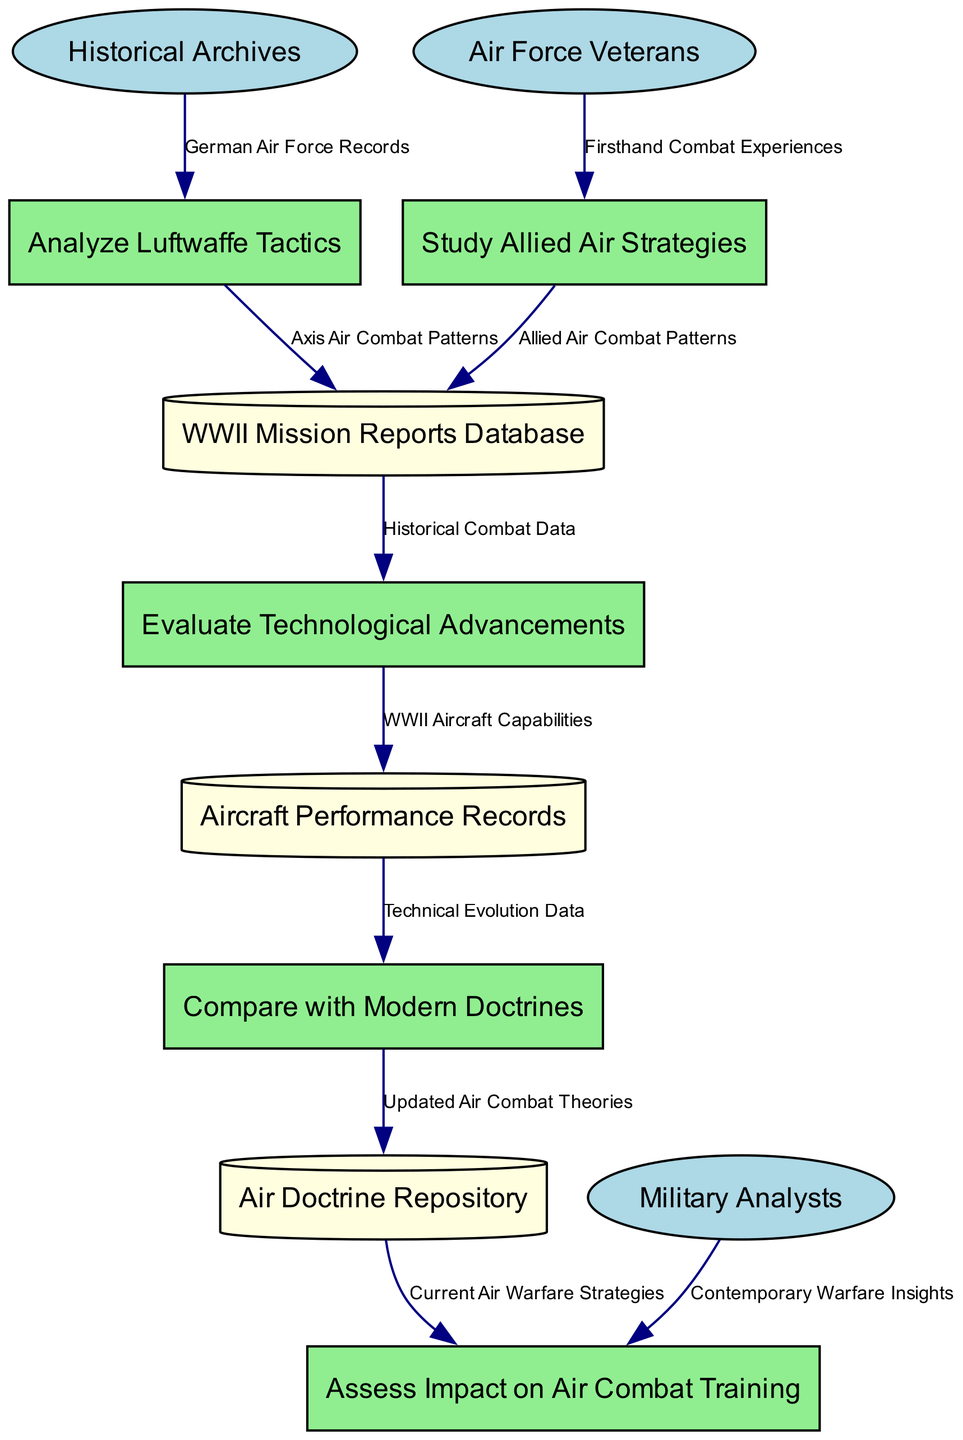What are the external entities involved in the analysis? The diagram lists three external entities: Historical Archives, Air Force Veterans, and Military Analysts. These entities provide data related to the WWII aerial combat analysis.
Answer: Historical Archives, Air Force Veterans, Military Analysts How many processes are present in the diagram? There are five processes in the diagram that relate to the analysis of aerial combat tactics. They include Analyze Luftwaffe Tactics, Study Allied Air Strategies, Evaluate Technological Advancements, Compare with Modern Doctrines, and Assess Impact on Air Combat Training.
Answer: Five What data flows from Historical Archives to Analyze Luftwaffe Tactics? The data flow from Historical Archives to Analyze Luftwaffe Tactics consists of German Air Force Records. This indicates the contribution of historical documents to the analysis of Luftwaffe strategies.
Answer: German Air Force Records What is the output of Evaluate Technological Advancements? The output of Evaluate Technological Advancements is linked to Aircraft Performance Records and consists of WWII Aircraft Capabilities, which signifies the evaluation of aircraft technology during WWII.
Answer: WWII Aircraft Capabilities Which process utilizes firsthand combat experiences? The process that utilizes firsthand combat experiences is Study Allied Air Strategies. This process draws from the experiences of Air Force Veterans to gain insights into Allied strategies.
Answer: Study Allied Air Strategies What is the relationship between Aircraft Performance Records and Compare with Modern Doctrines? The relationship is that Aircraft Performance Records provides Technical Evolution Data to Compare with Modern Doctrines, which is crucial for assessing how past technologies influence current strategies.
Answer: Technical Evolution Data What is the final destination of data coming from the Air Doctrine Repository? The final destination of the data coming from the Air Doctrine Repository is Assess Impact on Air Combat Training, indicating that the updated air combat theories derived from historical analysis influence training practices.
Answer: Assess Impact on Air Combat Training Which entities provide input for assessing the impact on air combat training? The input for assessing the impact on air combat training comes from the Air Doctrine Repository and Military Analysts, indicating a combination of historical doctrine and contemporary insights for evaluation.
Answer: Air Doctrine Repository, Military Analysts 